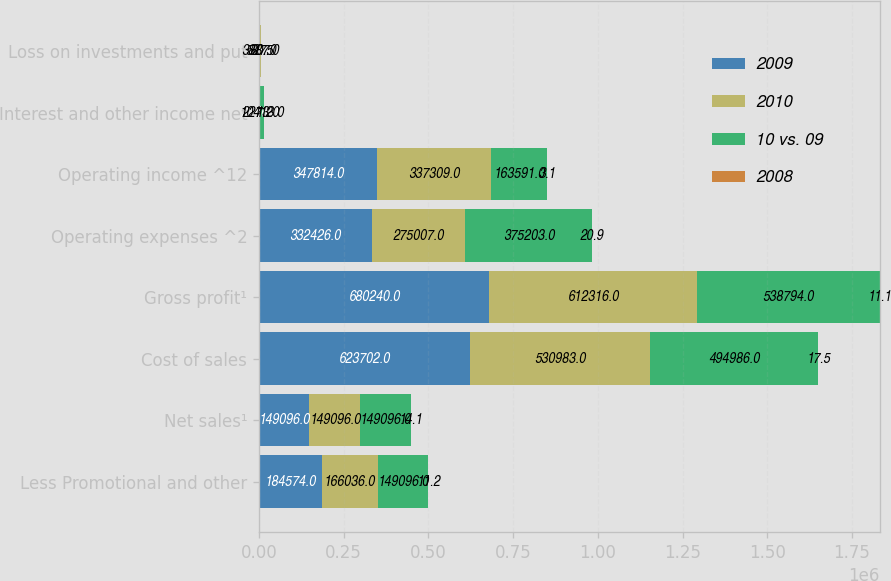Convert chart. <chart><loc_0><loc_0><loc_500><loc_500><stacked_bar_chart><ecel><fcel>Less Promotional and other<fcel>Net sales¹<fcel>Cost of sales<fcel>Gross profit¹<fcel>Operating expenses ^2<fcel>Operating income ^12<fcel>Interest and other income net<fcel>Loss on investments and put<nl><fcel>2009<fcel>184574<fcel>149096<fcel>623702<fcel>680240<fcel>332426<fcel>347814<fcel>2246<fcel>758<nl><fcel>2010<fcel>166036<fcel>149096<fcel>530983<fcel>612316<fcel>275007<fcel>337309<fcel>2273<fcel>3887<nl><fcel>10 vs. 09<fcel>149096<fcel>149096<fcel>494986<fcel>538794<fcel>375203<fcel>163591<fcel>10413<fcel>527<nl><fcel>2008<fcel>11.2<fcel>14.1<fcel>17.5<fcel>11.1<fcel>20.9<fcel>3.1<fcel>1.2<fcel>80.5<nl></chart> 